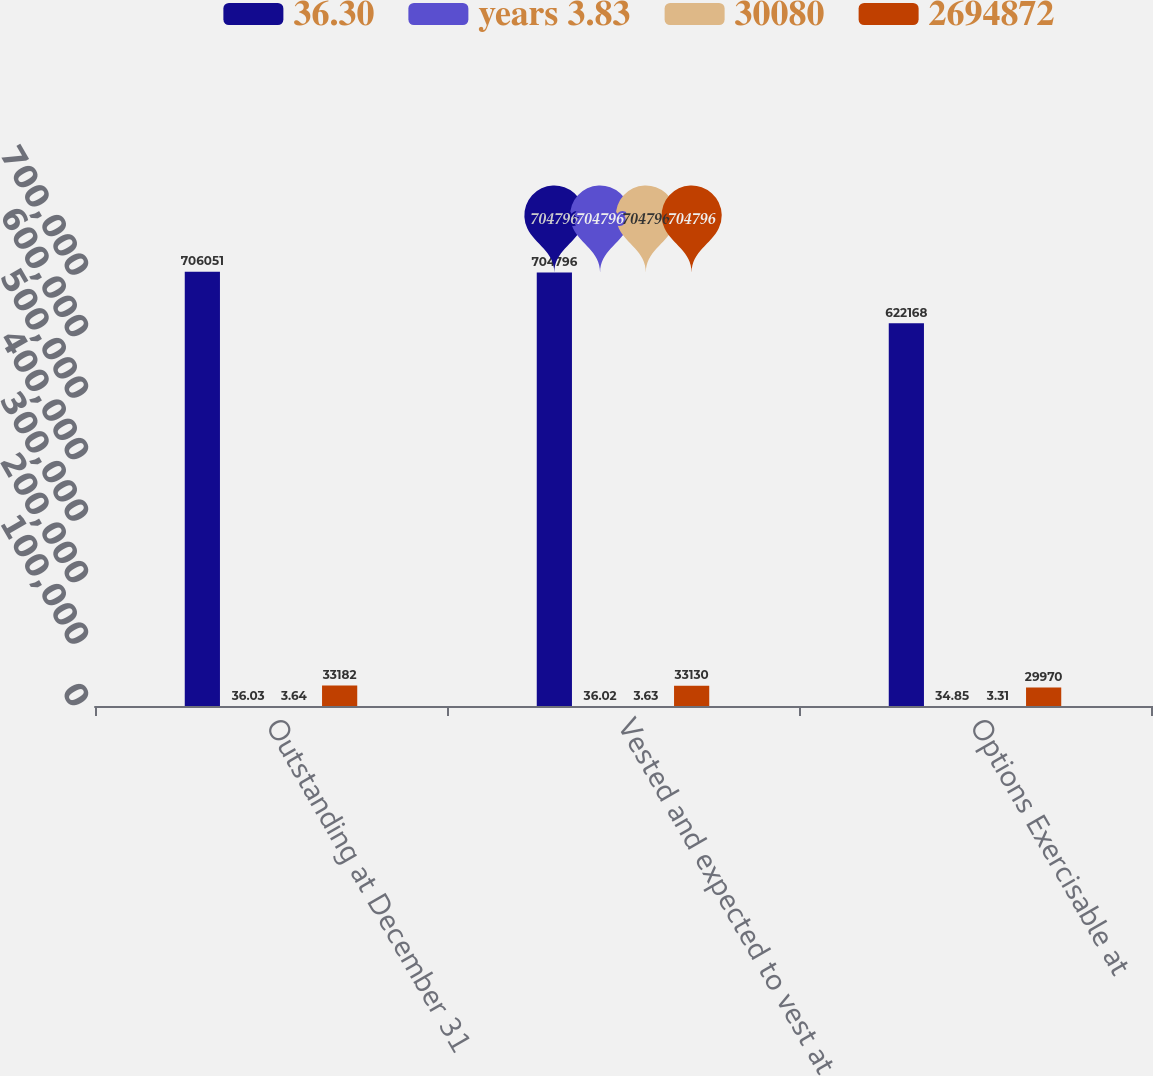Convert chart. <chart><loc_0><loc_0><loc_500><loc_500><stacked_bar_chart><ecel><fcel>Outstanding at December 31<fcel>Vested and expected to vest at<fcel>Options Exercisable at<nl><fcel>36.30<fcel>706051<fcel>704796<fcel>622168<nl><fcel>years 3.83<fcel>36.03<fcel>36.02<fcel>34.85<nl><fcel>30080<fcel>3.64<fcel>3.63<fcel>3.31<nl><fcel>2694872<fcel>33182<fcel>33130<fcel>29970<nl></chart> 